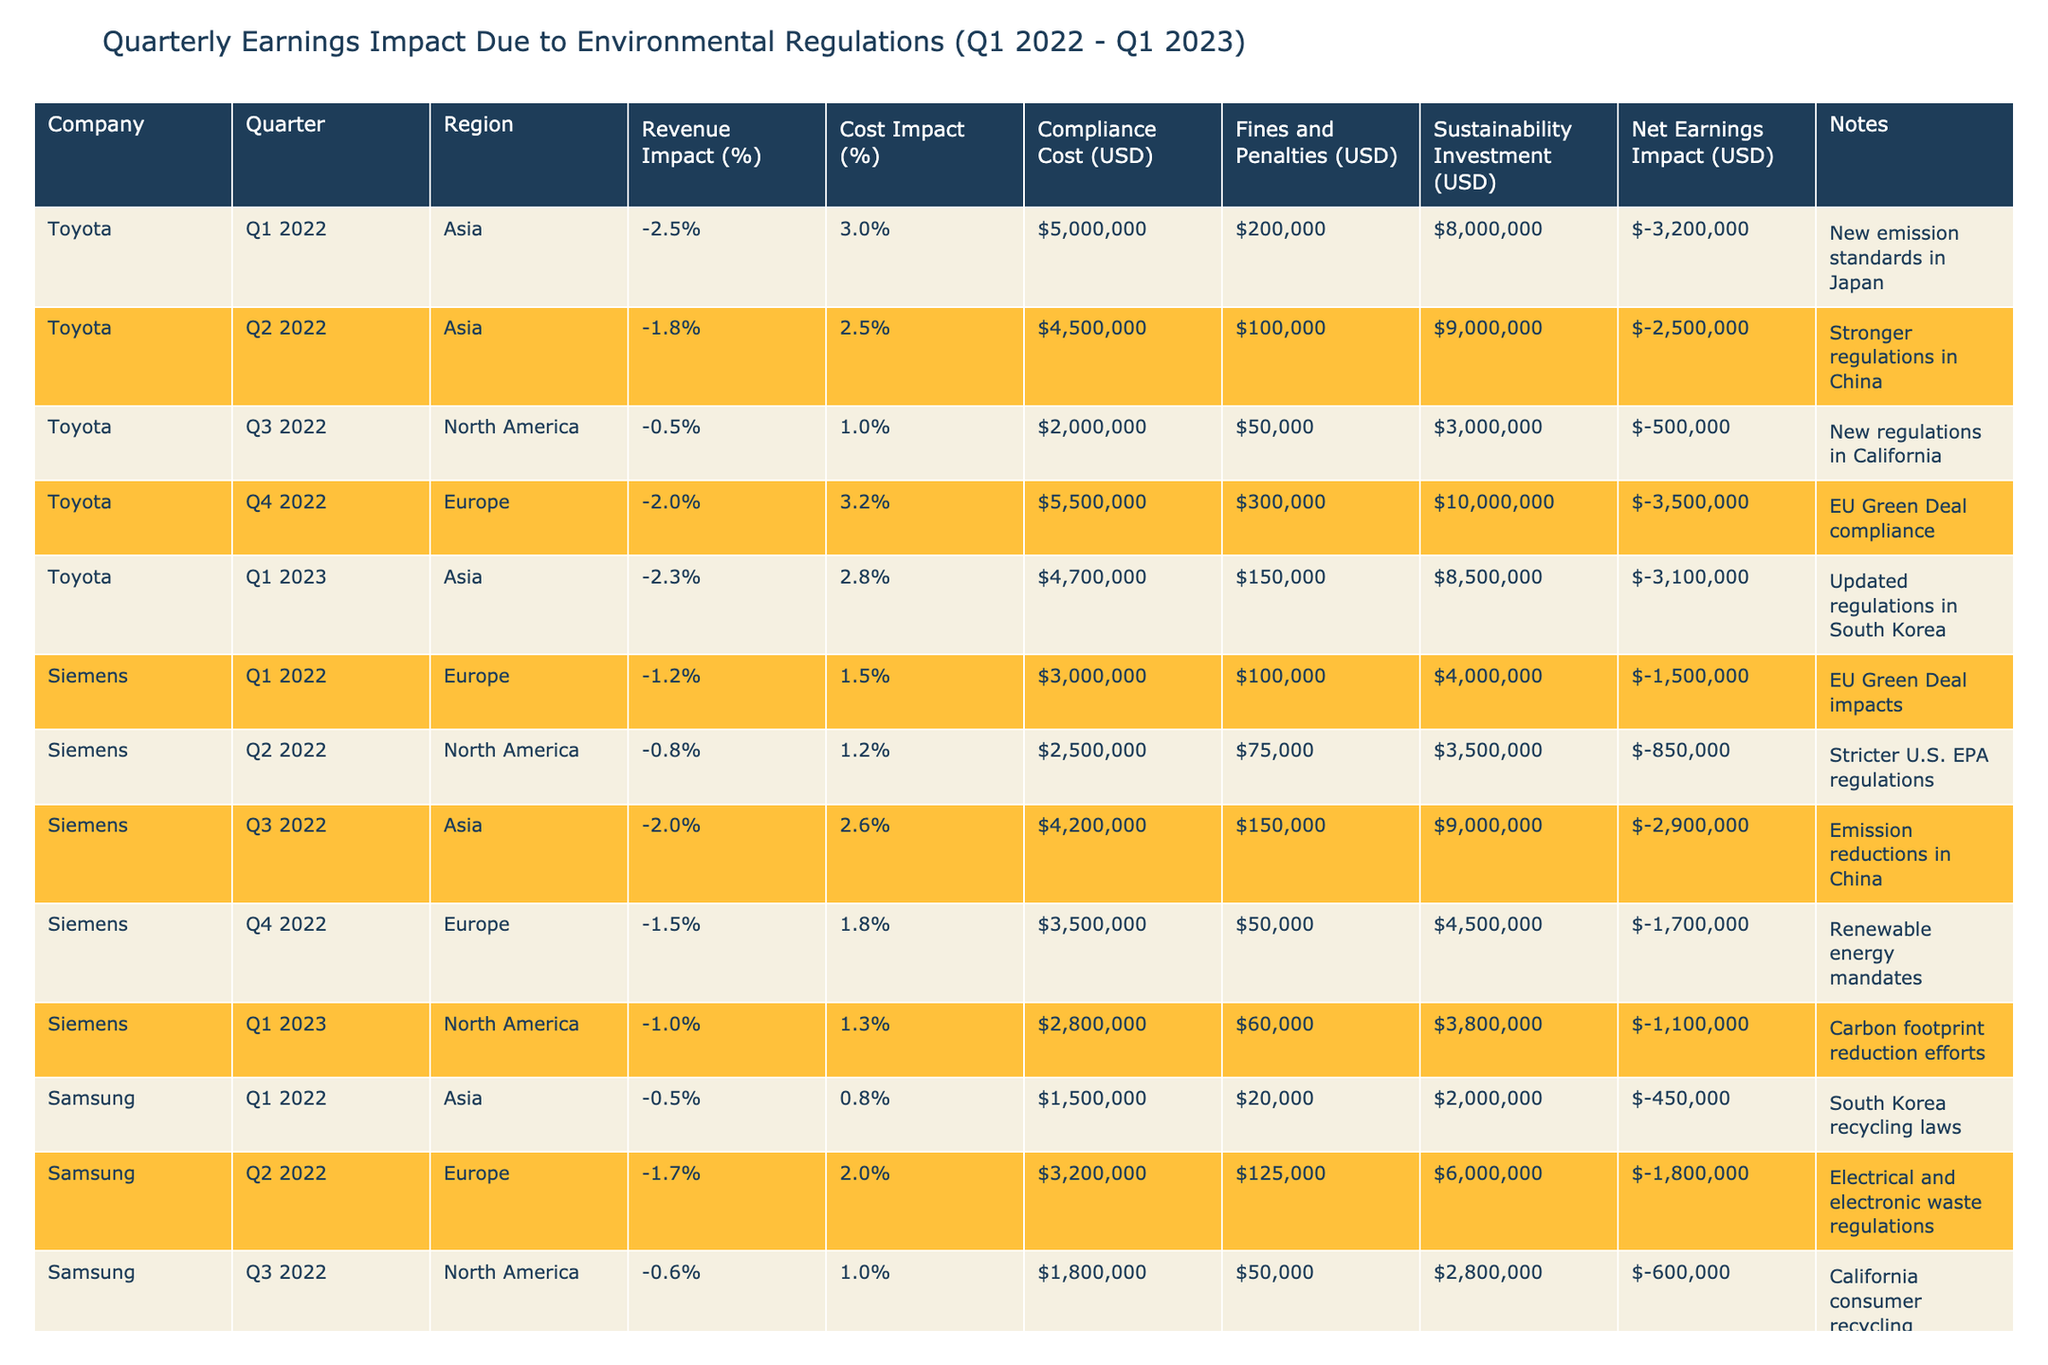What was the largest net earnings impact reported for Toyota during the observed quarters? In the table, the net earnings impact for Toyota across all quarters is listed as -3200000, -2500000, -500000, -3500000, and -3100000. The largest (least negative) value is -500000, found in Q3 2022.
Answer: -500000 Which company faced the highest compliance cost in Q1 2023? For Q1 2023, the compliance costs are listed: Toyota at 4700000, Siemens at 2800000, Samsung at 2500000, and Volkswagen at 5000000. Among these, Volkswagen has the highest compliance cost at 5000000.
Answer: 5000000 Was the revenue impact for Samsung in Q4 2022 worse than in Q3 2022? In Q4 2022, Samsung's revenue impact is -1.8%, and in Q3 2022, it is -0.6%. Since -1.8% is lower than -0.6%, the revenue impact in Q4 2022 was indeed worse.
Answer: Yes What is the total net earnings impact for Siemens over the observed quarters? The net earnings impacts for Siemens are -1500000, -850000, -2900000, -1700000, and -1100000. Summing these gives -1500000 + -850000 + -2900000 + -1700000 + -1100000 = -10350000.
Answer: -10350000 Did any company report a net earnings impact better than -1 million in Q2 2022? In Q2 2022, the net earnings impacts reported are Toyota at -2500000, Siemens at -850000, Samsung at -1800000, and Volkswagen at -1800000. Siemens, with a net earnings impact of -850000, is better than -1 million.
Answer: Yes What is the average compliance cost for all companies in Q1 2022? The compliance costs for Q1 2022 are: Toyota at 5000000, Siemens at 3000000, Samsung at 1500000, and Volkswagen at 6200000. Adding these up gives a total compliance cost of 5000000 + 3000000 + 1500000 + 6200000 = 15700000. There are 4 companies, so the average is 15700000 / 4 = 3925000.
Answer: 3925000 Which region had the worst revenue impact for Volkswagen during Q1 2023? In Q1 2023, Volkswagen's revenue impact in Asia is -2.1%. No other regions are listed for Q1 2023. Thus, -2.1% is the only revenue impact for this quarter, indicating it is the worst.
Answer: -2.1% How did the compliance costs for Toyota and Volkswagen compare in Q4 2022? Toyota's compliance cost in Q4 2022 is 5500000 and Volkswagen's is 5500000 as well. Since both values are equal, there is no difference between the compliance costs for Toyota and Volkswagen in this quarter.
Answer: Equal 